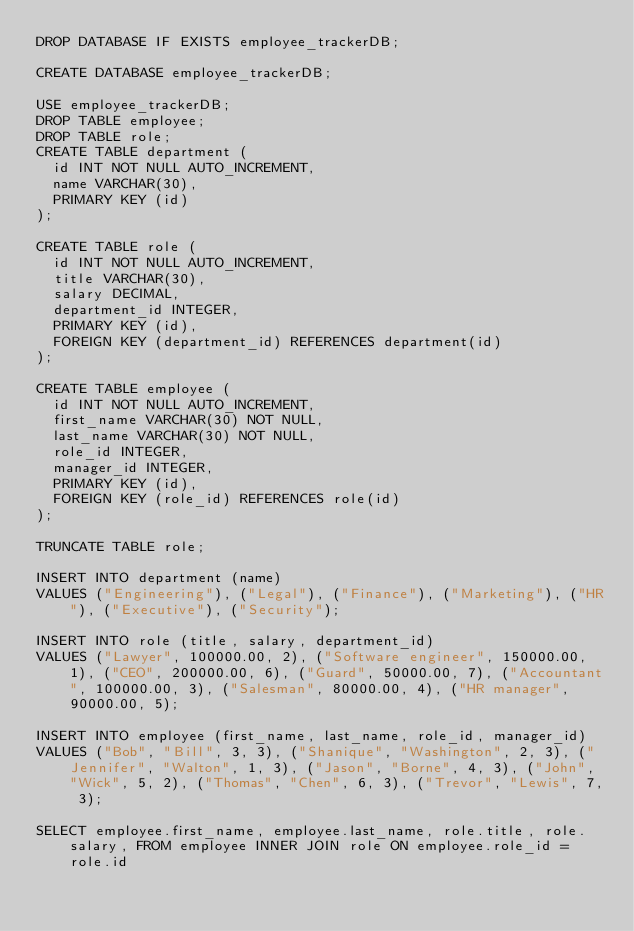<code> <loc_0><loc_0><loc_500><loc_500><_SQL_>DROP DATABASE IF EXISTS employee_trackerDB;

CREATE DATABASE employee_trackerDB;

USE employee_trackerDB;
DROP TABLE employee;
DROP TABLE role;
CREATE TABLE department (
  id INT NOT NULL AUTO_INCREMENT,
  name VARCHAR(30),
  PRIMARY KEY (id)
);

CREATE TABLE role (
  id INT NOT NULL AUTO_INCREMENT,
  title VARCHAR(30),
  salary DECIMAL,
  department_id INTEGER,
  PRIMARY KEY (id),
  FOREIGN KEY (department_id) REFERENCES department(id)
);

CREATE TABLE employee (
  id INT NOT NULL AUTO_INCREMENT,
  first_name VARCHAR(30) NOT NULL,
  last_name VARCHAR(30) NOT NULL,
  role_id INTEGER,
  manager_id INTEGER,
  PRIMARY KEY (id),
  FOREIGN KEY (role_id) REFERENCES role(id)
);

TRUNCATE TABLE role;

INSERT INTO department (name)
VALUES ("Engineering"), ("Legal"), ("Finance"), ("Marketing"), ("HR"), ("Executive"), ("Security");

INSERT INTO role (title, salary, department_id)
VALUES ("Lawyer", 100000.00, 2), ("Software engineer", 150000.00, 1), ("CEO", 200000.00, 6), ("Guard", 50000.00, 7), ("Accountant", 100000.00, 3), ("Salesman", 80000.00, 4), ("HR manager", 90000.00, 5);

INSERT INTO employee (first_name, last_name, role_id, manager_id)
VALUES ("Bob", "Bill", 3, 3), ("Shanique", "Washington", 2, 3), ("Jennifer", "Walton", 1, 3), ("Jason", "Borne", 4, 3), ("John", "Wick", 5, 2), ("Thomas", "Chen", 6, 3), ("Trevor", "Lewis", 7, 3);

SELECT employee.first_name, employee.last_name, role.title, role.salary, FROM employee INNER JOIN role ON employee.role_id = role.id</code> 